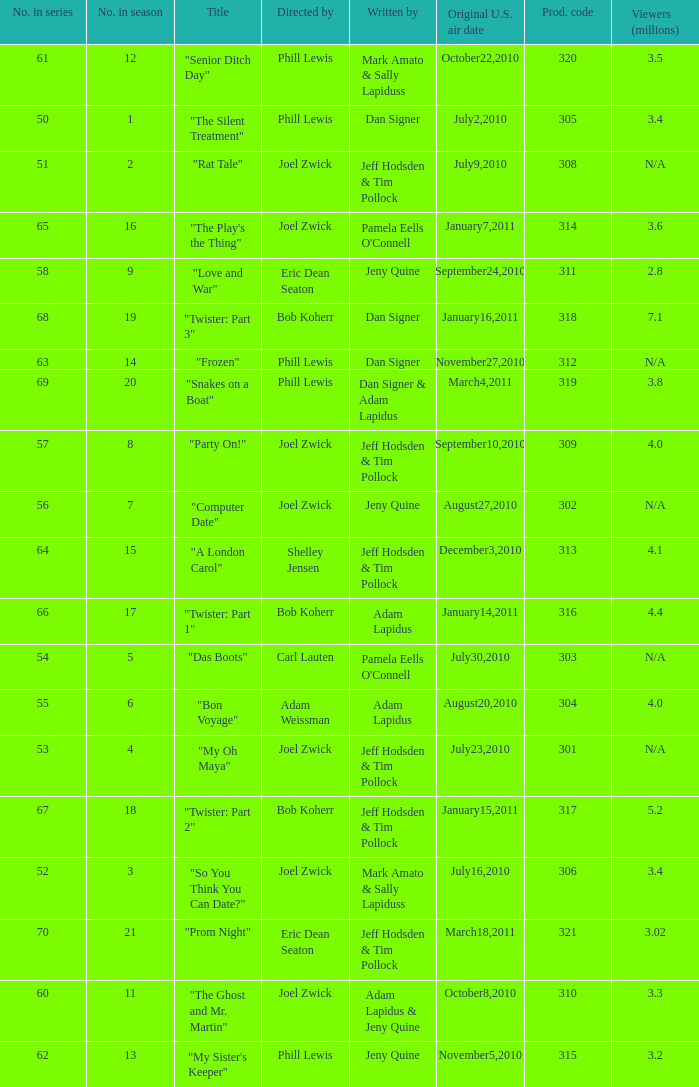How many million viewers watched episode 6? 4.0. 